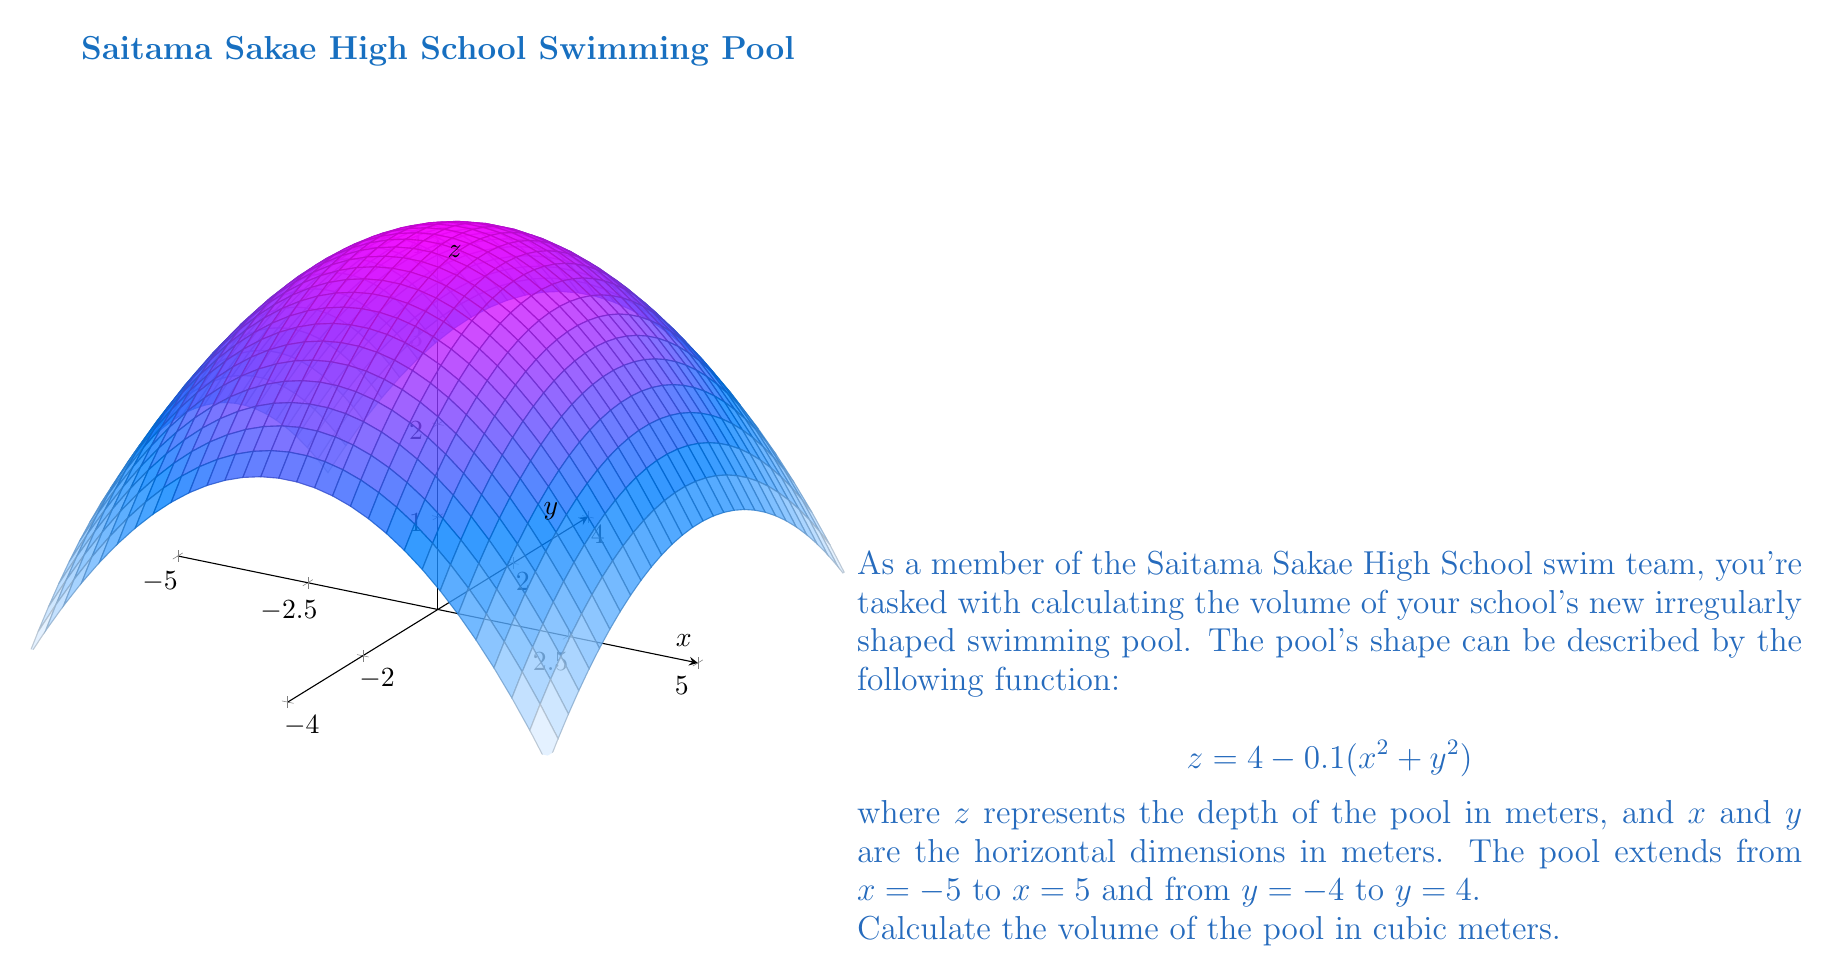Show me your answer to this math problem. Let's approach this step-by-step:

1) The volume of the pool can be calculated using a double integral:

   $$V = \iint_R (4 - 0.1(x^2 + y^2)) \, dA$$

   where $R$ is the region of integration.

2) The limits of integration are:
   $-5 \leq x \leq 5$ and $-4 \leq y \leq 4$

3) We can set up the double integral:

   $$V = \int_{-4}^{4} \int_{-5}^{5} (4 - 0.1(x^2 + y^2)) \, dx \, dy$$

4) Let's solve the inner integral first:

   $$\int_{-5}^{5} (4 - 0.1(x^2 + y^2)) \, dx = [4x - \frac{0.1x^3}{3} - 0.1xy^2]_{-5}^{5}$$

   $$= (20 - \frac{25}{3} - 0.5y^2) - (-20 - \frac{25}{3} - 0.5y^2) = 40 - \frac{50}{3}$$

5) Now our integral becomes:

   $$V = \int_{-4}^{4} (40 - \frac{50}{3}) \, dy = (40 - \frac{50}{3}) \int_{-4}^{4} \, dy$$

6) Solving this:

   $$V = (40 - \frac{50}{3}) \cdot 8 = 320 - \frac{400}{3} = \frac{560}{3}$$

7) Therefore, the volume of the pool is $\frac{560}{3}$ cubic meters.
Answer: $\frac{560}{3}$ m³ 